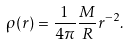<formula> <loc_0><loc_0><loc_500><loc_500>\rho ( r ) = \frac { 1 } { 4 \pi } \frac { M } { R } r ^ { - 2 } .</formula> 